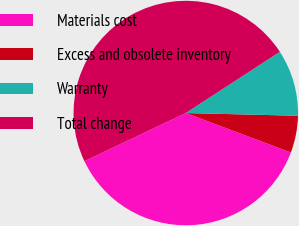Convert chart. <chart><loc_0><loc_0><loc_500><loc_500><pie_chart><fcel>Materials cost<fcel>Excess and obsolete inventory<fcel>Warranty<fcel>Total change<nl><fcel>37.23%<fcel>5.32%<fcel>9.57%<fcel>47.87%<nl></chart> 